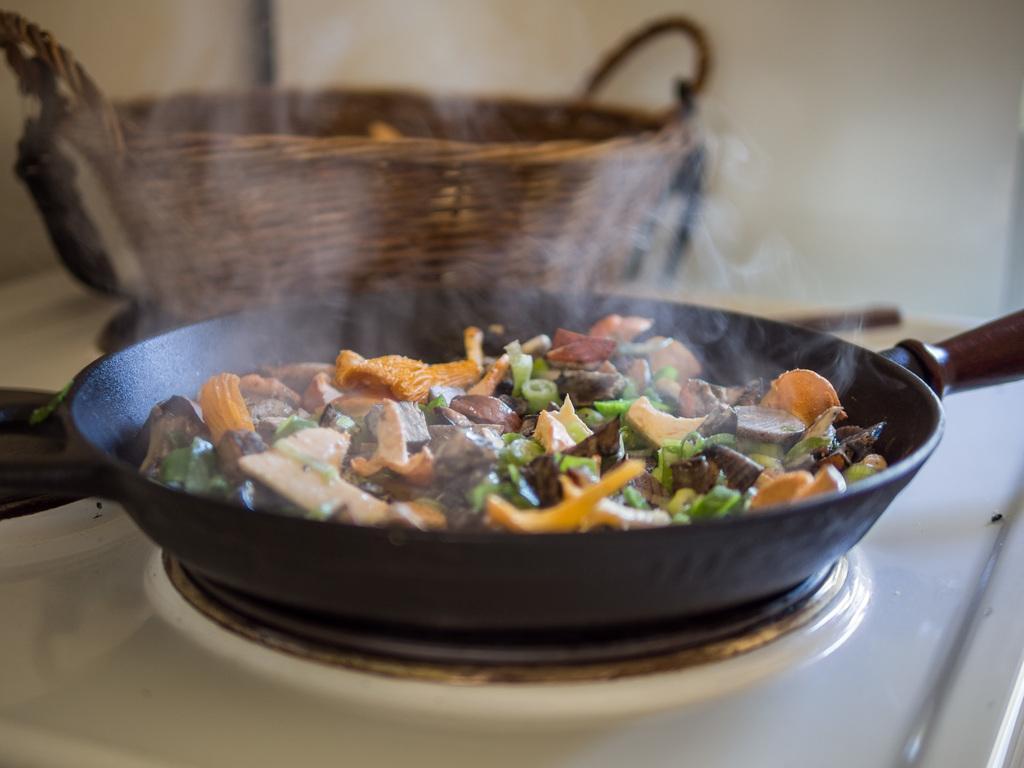Please provide a concise description of this image. In this image there is food on the pan which is in the center. In the background there is a basket. 